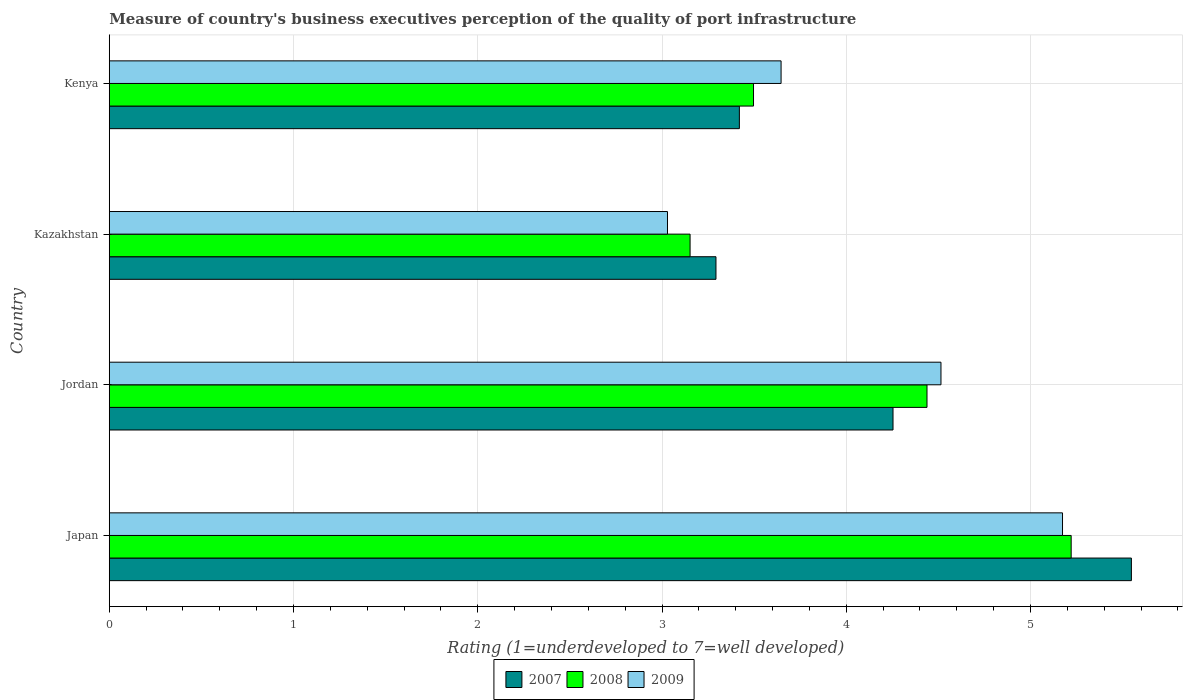How many different coloured bars are there?
Give a very brief answer. 3. How many groups of bars are there?
Provide a succinct answer. 4. Are the number of bars per tick equal to the number of legend labels?
Provide a short and direct response. Yes. Are the number of bars on each tick of the Y-axis equal?
Your answer should be compact. Yes. How many bars are there on the 4th tick from the top?
Keep it short and to the point. 3. How many bars are there on the 1st tick from the bottom?
Keep it short and to the point. 3. What is the label of the 2nd group of bars from the top?
Keep it short and to the point. Kazakhstan. What is the ratings of the quality of port infrastructure in 2008 in Japan?
Your answer should be compact. 5.22. Across all countries, what is the maximum ratings of the quality of port infrastructure in 2007?
Keep it short and to the point. 5.55. Across all countries, what is the minimum ratings of the quality of port infrastructure in 2009?
Your response must be concise. 3.03. In which country was the ratings of the quality of port infrastructure in 2009 minimum?
Your response must be concise. Kazakhstan. What is the total ratings of the quality of port infrastructure in 2007 in the graph?
Provide a short and direct response. 16.51. What is the difference between the ratings of the quality of port infrastructure in 2007 in Japan and that in Kenya?
Ensure brevity in your answer.  2.13. What is the difference between the ratings of the quality of port infrastructure in 2007 in Kazakhstan and the ratings of the quality of port infrastructure in 2008 in Kenya?
Provide a succinct answer. -0.2. What is the average ratings of the quality of port infrastructure in 2008 per country?
Your answer should be compact. 4.08. What is the difference between the ratings of the quality of port infrastructure in 2009 and ratings of the quality of port infrastructure in 2008 in Japan?
Offer a terse response. -0.05. What is the ratio of the ratings of the quality of port infrastructure in 2007 in Kazakhstan to that in Kenya?
Your answer should be compact. 0.96. Is the difference between the ratings of the quality of port infrastructure in 2009 in Jordan and Kazakhstan greater than the difference between the ratings of the quality of port infrastructure in 2008 in Jordan and Kazakhstan?
Provide a succinct answer. Yes. What is the difference between the highest and the second highest ratings of the quality of port infrastructure in 2007?
Your answer should be compact. 1.29. What is the difference between the highest and the lowest ratings of the quality of port infrastructure in 2007?
Make the answer very short. 2.25. In how many countries, is the ratings of the quality of port infrastructure in 2008 greater than the average ratings of the quality of port infrastructure in 2008 taken over all countries?
Your answer should be very brief. 2. What does the 2nd bar from the top in Kazakhstan represents?
Ensure brevity in your answer.  2008. What does the 2nd bar from the bottom in Jordan represents?
Provide a succinct answer. 2008. Is it the case that in every country, the sum of the ratings of the quality of port infrastructure in 2008 and ratings of the quality of port infrastructure in 2009 is greater than the ratings of the quality of port infrastructure in 2007?
Offer a very short reply. Yes. What is the difference between two consecutive major ticks on the X-axis?
Provide a succinct answer. 1. Are the values on the major ticks of X-axis written in scientific E-notation?
Offer a very short reply. No. Does the graph contain any zero values?
Provide a succinct answer. No. Where does the legend appear in the graph?
Your response must be concise. Bottom center. How are the legend labels stacked?
Your answer should be compact. Horizontal. What is the title of the graph?
Keep it short and to the point. Measure of country's business executives perception of the quality of port infrastructure. Does "1964" appear as one of the legend labels in the graph?
Your answer should be compact. No. What is the label or title of the X-axis?
Keep it short and to the point. Rating (1=underdeveloped to 7=well developed). What is the label or title of the Y-axis?
Your answer should be very brief. Country. What is the Rating (1=underdeveloped to 7=well developed) in 2007 in Japan?
Your response must be concise. 5.55. What is the Rating (1=underdeveloped to 7=well developed) in 2008 in Japan?
Make the answer very short. 5.22. What is the Rating (1=underdeveloped to 7=well developed) of 2009 in Japan?
Provide a short and direct response. 5.17. What is the Rating (1=underdeveloped to 7=well developed) of 2007 in Jordan?
Your answer should be compact. 4.25. What is the Rating (1=underdeveloped to 7=well developed) in 2008 in Jordan?
Offer a very short reply. 4.44. What is the Rating (1=underdeveloped to 7=well developed) in 2009 in Jordan?
Your response must be concise. 4.51. What is the Rating (1=underdeveloped to 7=well developed) in 2007 in Kazakhstan?
Offer a terse response. 3.29. What is the Rating (1=underdeveloped to 7=well developed) in 2008 in Kazakhstan?
Your answer should be compact. 3.15. What is the Rating (1=underdeveloped to 7=well developed) of 2009 in Kazakhstan?
Give a very brief answer. 3.03. What is the Rating (1=underdeveloped to 7=well developed) in 2007 in Kenya?
Make the answer very short. 3.42. What is the Rating (1=underdeveloped to 7=well developed) in 2008 in Kenya?
Make the answer very short. 3.5. What is the Rating (1=underdeveloped to 7=well developed) of 2009 in Kenya?
Offer a very short reply. 3.65. Across all countries, what is the maximum Rating (1=underdeveloped to 7=well developed) in 2007?
Offer a terse response. 5.55. Across all countries, what is the maximum Rating (1=underdeveloped to 7=well developed) in 2008?
Offer a terse response. 5.22. Across all countries, what is the maximum Rating (1=underdeveloped to 7=well developed) in 2009?
Offer a very short reply. 5.17. Across all countries, what is the minimum Rating (1=underdeveloped to 7=well developed) of 2007?
Provide a succinct answer. 3.29. Across all countries, what is the minimum Rating (1=underdeveloped to 7=well developed) of 2008?
Make the answer very short. 3.15. Across all countries, what is the minimum Rating (1=underdeveloped to 7=well developed) in 2009?
Your answer should be compact. 3.03. What is the total Rating (1=underdeveloped to 7=well developed) in 2007 in the graph?
Make the answer very short. 16.51. What is the total Rating (1=underdeveloped to 7=well developed) of 2008 in the graph?
Your response must be concise. 16.31. What is the total Rating (1=underdeveloped to 7=well developed) in 2009 in the graph?
Keep it short and to the point. 16.36. What is the difference between the Rating (1=underdeveloped to 7=well developed) in 2007 in Japan and that in Jordan?
Provide a short and direct response. 1.29. What is the difference between the Rating (1=underdeveloped to 7=well developed) of 2008 in Japan and that in Jordan?
Give a very brief answer. 0.78. What is the difference between the Rating (1=underdeveloped to 7=well developed) of 2009 in Japan and that in Jordan?
Offer a terse response. 0.66. What is the difference between the Rating (1=underdeveloped to 7=well developed) in 2007 in Japan and that in Kazakhstan?
Provide a succinct answer. 2.25. What is the difference between the Rating (1=underdeveloped to 7=well developed) of 2008 in Japan and that in Kazakhstan?
Offer a very short reply. 2.07. What is the difference between the Rating (1=underdeveloped to 7=well developed) in 2009 in Japan and that in Kazakhstan?
Your answer should be compact. 2.14. What is the difference between the Rating (1=underdeveloped to 7=well developed) in 2007 in Japan and that in Kenya?
Give a very brief answer. 2.13. What is the difference between the Rating (1=underdeveloped to 7=well developed) of 2008 in Japan and that in Kenya?
Offer a very short reply. 1.72. What is the difference between the Rating (1=underdeveloped to 7=well developed) of 2009 in Japan and that in Kenya?
Provide a short and direct response. 1.53. What is the difference between the Rating (1=underdeveloped to 7=well developed) in 2007 in Jordan and that in Kazakhstan?
Make the answer very short. 0.96. What is the difference between the Rating (1=underdeveloped to 7=well developed) in 2008 in Jordan and that in Kazakhstan?
Your answer should be very brief. 1.29. What is the difference between the Rating (1=underdeveloped to 7=well developed) in 2009 in Jordan and that in Kazakhstan?
Your response must be concise. 1.48. What is the difference between the Rating (1=underdeveloped to 7=well developed) in 2007 in Jordan and that in Kenya?
Your response must be concise. 0.83. What is the difference between the Rating (1=underdeveloped to 7=well developed) in 2008 in Jordan and that in Kenya?
Your answer should be compact. 0.94. What is the difference between the Rating (1=underdeveloped to 7=well developed) of 2009 in Jordan and that in Kenya?
Ensure brevity in your answer.  0.87. What is the difference between the Rating (1=underdeveloped to 7=well developed) of 2007 in Kazakhstan and that in Kenya?
Offer a very short reply. -0.13. What is the difference between the Rating (1=underdeveloped to 7=well developed) in 2008 in Kazakhstan and that in Kenya?
Offer a terse response. -0.34. What is the difference between the Rating (1=underdeveloped to 7=well developed) in 2009 in Kazakhstan and that in Kenya?
Your answer should be very brief. -0.62. What is the difference between the Rating (1=underdeveloped to 7=well developed) in 2007 in Japan and the Rating (1=underdeveloped to 7=well developed) in 2008 in Jordan?
Make the answer very short. 1.11. What is the difference between the Rating (1=underdeveloped to 7=well developed) of 2007 in Japan and the Rating (1=underdeveloped to 7=well developed) of 2009 in Jordan?
Provide a succinct answer. 1.03. What is the difference between the Rating (1=underdeveloped to 7=well developed) of 2008 in Japan and the Rating (1=underdeveloped to 7=well developed) of 2009 in Jordan?
Your response must be concise. 0.71. What is the difference between the Rating (1=underdeveloped to 7=well developed) in 2007 in Japan and the Rating (1=underdeveloped to 7=well developed) in 2008 in Kazakhstan?
Offer a terse response. 2.4. What is the difference between the Rating (1=underdeveloped to 7=well developed) in 2007 in Japan and the Rating (1=underdeveloped to 7=well developed) in 2009 in Kazakhstan?
Offer a terse response. 2.52. What is the difference between the Rating (1=underdeveloped to 7=well developed) of 2008 in Japan and the Rating (1=underdeveloped to 7=well developed) of 2009 in Kazakhstan?
Provide a succinct answer. 2.19. What is the difference between the Rating (1=underdeveloped to 7=well developed) in 2007 in Japan and the Rating (1=underdeveloped to 7=well developed) in 2008 in Kenya?
Offer a very short reply. 2.05. What is the difference between the Rating (1=underdeveloped to 7=well developed) in 2007 in Japan and the Rating (1=underdeveloped to 7=well developed) in 2009 in Kenya?
Your answer should be compact. 1.9. What is the difference between the Rating (1=underdeveloped to 7=well developed) of 2008 in Japan and the Rating (1=underdeveloped to 7=well developed) of 2009 in Kenya?
Make the answer very short. 1.57. What is the difference between the Rating (1=underdeveloped to 7=well developed) in 2007 in Jordan and the Rating (1=underdeveloped to 7=well developed) in 2008 in Kazakhstan?
Provide a short and direct response. 1.1. What is the difference between the Rating (1=underdeveloped to 7=well developed) of 2007 in Jordan and the Rating (1=underdeveloped to 7=well developed) of 2009 in Kazakhstan?
Offer a terse response. 1.22. What is the difference between the Rating (1=underdeveloped to 7=well developed) of 2008 in Jordan and the Rating (1=underdeveloped to 7=well developed) of 2009 in Kazakhstan?
Provide a short and direct response. 1.41. What is the difference between the Rating (1=underdeveloped to 7=well developed) of 2007 in Jordan and the Rating (1=underdeveloped to 7=well developed) of 2008 in Kenya?
Your response must be concise. 0.76. What is the difference between the Rating (1=underdeveloped to 7=well developed) of 2007 in Jordan and the Rating (1=underdeveloped to 7=well developed) of 2009 in Kenya?
Give a very brief answer. 0.61. What is the difference between the Rating (1=underdeveloped to 7=well developed) of 2008 in Jordan and the Rating (1=underdeveloped to 7=well developed) of 2009 in Kenya?
Your answer should be very brief. 0.79. What is the difference between the Rating (1=underdeveloped to 7=well developed) of 2007 in Kazakhstan and the Rating (1=underdeveloped to 7=well developed) of 2008 in Kenya?
Offer a terse response. -0.2. What is the difference between the Rating (1=underdeveloped to 7=well developed) in 2007 in Kazakhstan and the Rating (1=underdeveloped to 7=well developed) in 2009 in Kenya?
Offer a terse response. -0.35. What is the difference between the Rating (1=underdeveloped to 7=well developed) of 2008 in Kazakhstan and the Rating (1=underdeveloped to 7=well developed) of 2009 in Kenya?
Your answer should be very brief. -0.49. What is the average Rating (1=underdeveloped to 7=well developed) of 2007 per country?
Provide a short and direct response. 4.13. What is the average Rating (1=underdeveloped to 7=well developed) of 2008 per country?
Your answer should be very brief. 4.08. What is the average Rating (1=underdeveloped to 7=well developed) of 2009 per country?
Ensure brevity in your answer.  4.09. What is the difference between the Rating (1=underdeveloped to 7=well developed) in 2007 and Rating (1=underdeveloped to 7=well developed) in 2008 in Japan?
Offer a terse response. 0.33. What is the difference between the Rating (1=underdeveloped to 7=well developed) in 2007 and Rating (1=underdeveloped to 7=well developed) in 2009 in Japan?
Offer a very short reply. 0.37. What is the difference between the Rating (1=underdeveloped to 7=well developed) in 2008 and Rating (1=underdeveloped to 7=well developed) in 2009 in Japan?
Provide a succinct answer. 0.05. What is the difference between the Rating (1=underdeveloped to 7=well developed) in 2007 and Rating (1=underdeveloped to 7=well developed) in 2008 in Jordan?
Keep it short and to the point. -0.18. What is the difference between the Rating (1=underdeveloped to 7=well developed) of 2007 and Rating (1=underdeveloped to 7=well developed) of 2009 in Jordan?
Your answer should be compact. -0.26. What is the difference between the Rating (1=underdeveloped to 7=well developed) in 2008 and Rating (1=underdeveloped to 7=well developed) in 2009 in Jordan?
Keep it short and to the point. -0.08. What is the difference between the Rating (1=underdeveloped to 7=well developed) in 2007 and Rating (1=underdeveloped to 7=well developed) in 2008 in Kazakhstan?
Keep it short and to the point. 0.14. What is the difference between the Rating (1=underdeveloped to 7=well developed) in 2007 and Rating (1=underdeveloped to 7=well developed) in 2009 in Kazakhstan?
Offer a very short reply. 0.26. What is the difference between the Rating (1=underdeveloped to 7=well developed) of 2008 and Rating (1=underdeveloped to 7=well developed) of 2009 in Kazakhstan?
Provide a short and direct response. 0.12. What is the difference between the Rating (1=underdeveloped to 7=well developed) of 2007 and Rating (1=underdeveloped to 7=well developed) of 2008 in Kenya?
Give a very brief answer. -0.08. What is the difference between the Rating (1=underdeveloped to 7=well developed) of 2007 and Rating (1=underdeveloped to 7=well developed) of 2009 in Kenya?
Your answer should be compact. -0.23. What is the difference between the Rating (1=underdeveloped to 7=well developed) in 2008 and Rating (1=underdeveloped to 7=well developed) in 2009 in Kenya?
Provide a succinct answer. -0.15. What is the ratio of the Rating (1=underdeveloped to 7=well developed) of 2007 in Japan to that in Jordan?
Provide a short and direct response. 1.3. What is the ratio of the Rating (1=underdeveloped to 7=well developed) in 2008 in Japan to that in Jordan?
Provide a succinct answer. 1.18. What is the ratio of the Rating (1=underdeveloped to 7=well developed) of 2009 in Japan to that in Jordan?
Make the answer very short. 1.15. What is the ratio of the Rating (1=underdeveloped to 7=well developed) in 2007 in Japan to that in Kazakhstan?
Your response must be concise. 1.68. What is the ratio of the Rating (1=underdeveloped to 7=well developed) of 2008 in Japan to that in Kazakhstan?
Offer a very short reply. 1.66. What is the ratio of the Rating (1=underdeveloped to 7=well developed) in 2009 in Japan to that in Kazakhstan?
Provide a short and direct response. 1.71. What is the ratio of the Rating (1=underdeveloped to 7=well developed) of 2007 in Japan to that in Kenya?
Your answer should be compact. 1.62. What is the ratio of the Rating (1=underdeveloped to 7=well developed) in 2008 in Japan to that in Kenya?
Give a very brief answer. 1.49. What is the ratio of the Rating (1=underdeveloped to 7=well developed) of 2009 in Japan to that in Kenya?
Your answer should be very brief. 1.42. What is the ratio of the Rating (1=underdeveloped to 7=well developed) in 2007 in Jordan to that in Kazakhstan?
Your answer should be compact. 1.29. What is the ratio of the Rating (1=underdeveloped to 7=well developed) in 2008 in Jordan to that in Kazakhstan?
Keep it short and to the point. 1.41. What is the ratio of the Rating (1=underdeveloped to 7=well developed) of 2009 in Jordan to that in Kazakhstan?
Give a very brief answer. 1.49. What is the ratio of the Rating (1=underdeveloped to 7=well developed) in 2007 in Jordan to that in Kenya?
Your response must be concise. 1.24. What is the ratio of the Rating (1=underdeveloped to 7=well developed) in 2008 in Jordan to that in Kenya?
Offer a very short reply. 1.27. What is the ratio of the Rating (1=underdeveloped to 7=well developed) of 2009 in Jordan to that in Kenya?
Your response must be concise. 1.24. What is the ratio of the Rating (1=underdeveloped to 7=well developed) of 2007 in Kazakhstan to that in Kenya?
Offer a very short reply. 0.96. What is the ratio of the Rating (1=underdeveloped to 7=well developed) in 2008 in Kazakhstan to that in Kenya?
Provide a short and direct response. 0.9. What is the ratio of the Rating (1=underdeveloped to 7=well developed) of 2009 in Kazakhstan to that in Kenya?
Your answer should be compact. 0.83. What is the difference between the highest and the second highest Rating (1=underdeveloped to 7=well developed) of 2007?
Give a very brief answer. 1.29. What is the difference between the highest and the second highest Rating (1=underdeveloped to 7=well developed) in 2008?
Offer a very short reply. 0.78. What is the difference between the highest and the second highest Rating (1=underdeveloped to 7=well developed) of 2009?
Make the answer very short. 0.66. What is the difference between the highest and the lowest Rating (1=underdeveloped to 7=well developed) of 2007?
Offer a terse response. 2.25. What is the difference between the highest and the lowest Rating (1=underdeveloped to 7=well developed) of 2008?
Offer a very short reply. 2.07. What is the difference between the highest and the lowest Rating (1=underdeveloped to 7=well developed) in 2009?
Keep it short and to the point. 2.14. 